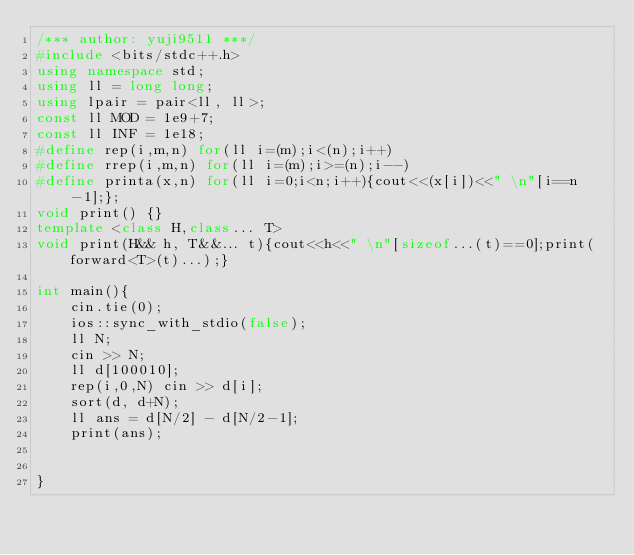<code> <loc_0><loc_0><loc_500><loc_500><_C++_>/*** author: yuji9511 ***/
#include <bits/stdc++.h>
using namespace std;
using ll = long long;
using lpair = pair<ll, ll>;
const ll MOD = 1e9+7;
const ll INF = 1e18;
#define rep(i,m,n) for(ll i=(m);i<(n);i++)
#define rrep(i,m,n) for(ll i=(m);i>=(n);i--)
#define printa(x,n) for(ll i=0;i<n;i++){cout<<(x[i])<<" \n"[i==n-1];};
void print() {}
template <class H,class... T>
void print(H&& h, T&&... t){cout<<h<<" \n"[sizeof...(t)==0];print(forward<T>(t)...);}

int main(){
    cin.tie(0);
    ios::sync_with_stdio(false);
    ll N;
    cin >> N;
    ll d[100010];
    rep(i,0,N) cin >> d[i];
    sort(d, d+N);
    ll ans = d[N/2] - d[N/2-1];
    print(ans);
    

}</code> 